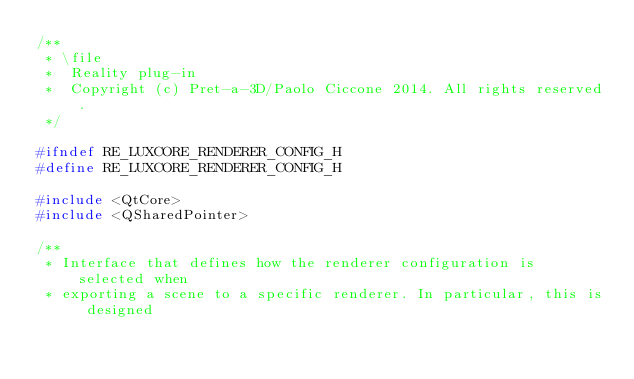<code> <loc_0><loc_0><loc_500><loc_500><_C_>/**
 * \file
 *  Reality plug-in
 *  Copyright (c) Pret-a-3D/Paolo Ciccone 2014. All rights reserved.    
 */

#ifndef RE_LUXCORE_RENDERER_CONFIG_H
#define RE_LUXCORE_RENDERER_CONFIG_H

#include <QtCore>
#include <QSharedPointer>

/**
 * Interface that defines how the renderer configuration is selected when
 * exporting a scene to a specific renderer. In particular, this is designed</code> 